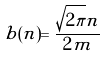Convert formula to latex. <formula><loc_0><loc_0><loc_500><loc_500>b ( n ) = \frac { \sqrt { 2 \pi } n } { 2 m }</formula> 